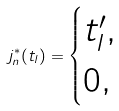<formula> <loc_0><loc_0><loc_500><loc_500>j _ { n } ^ { * } ( t _ { l } ) = \begin{cases} t _ { l } ^ { \prime } , & \\ 0 , & \end{cases}</formula> 